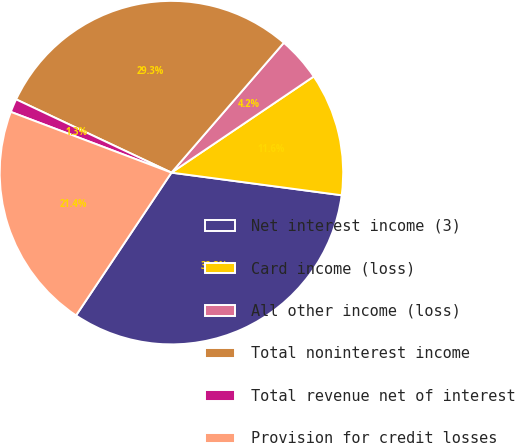<chart> <loc_0><loc_0><loc_500><loc_500><pie_chart><fcel>Net interest income (3)<fcel>Card income (loss)<fcel>All other income (loss)<fcel>Total noninterest income<fcel>Total revenue net of interest<fcel>Provision for credit losses<nl><fcel>32.27%<fcel>11.56%<fcel>4.19%<fcel>29.34%<fcel>1.26%<fcel>21.38%<nl></chart> 